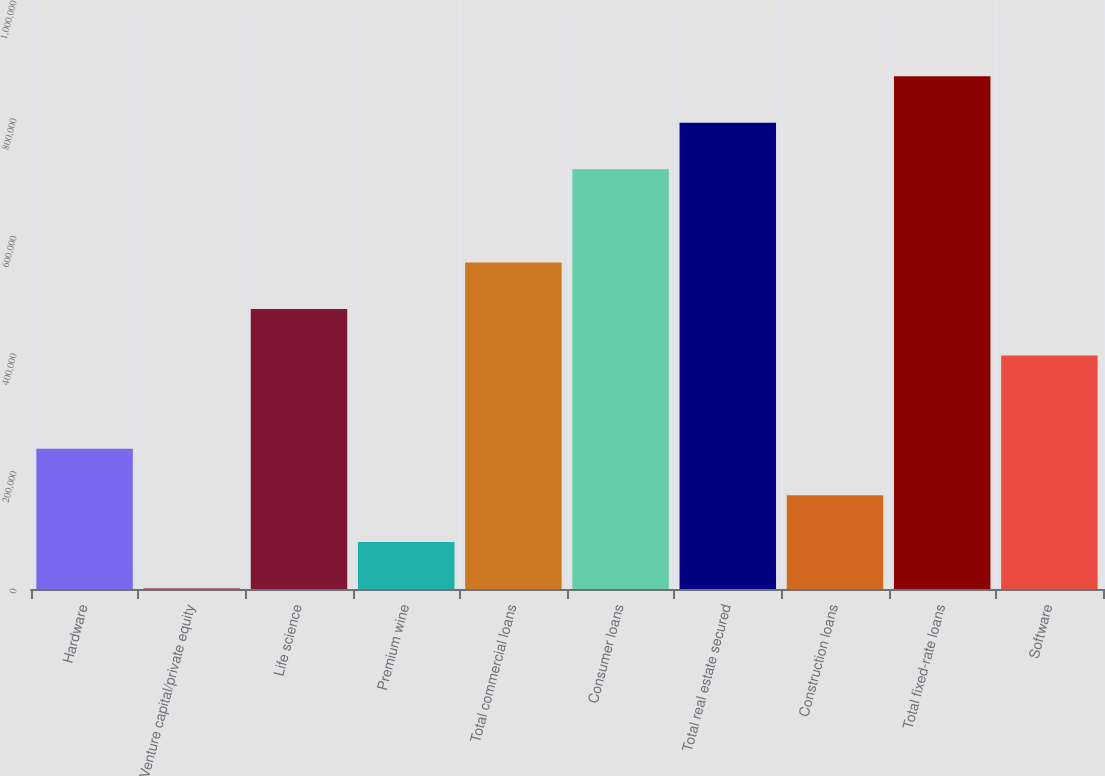Convert chart to OTSL. <chart><loc_0><loc_0><loc_500><loc_500><bar_chart><fcel>Hardware<fcel>Venture capital/private equity<fcel>Life science<fcel>Premium wine<fcel>Total commercial loans<fcel>Consumer loans<fcel>Total real estate secured<fcel>Construction loans<fcel>Total fixed-rate loans<fcel>Software<nl><fcel>238520<fcel>900<fcel>476141<fcel>80106.8<fcel>555348<fcel>713761<fcel>792968<fcel>159314<fcel>872175<fcel>396934<nl></chart> 